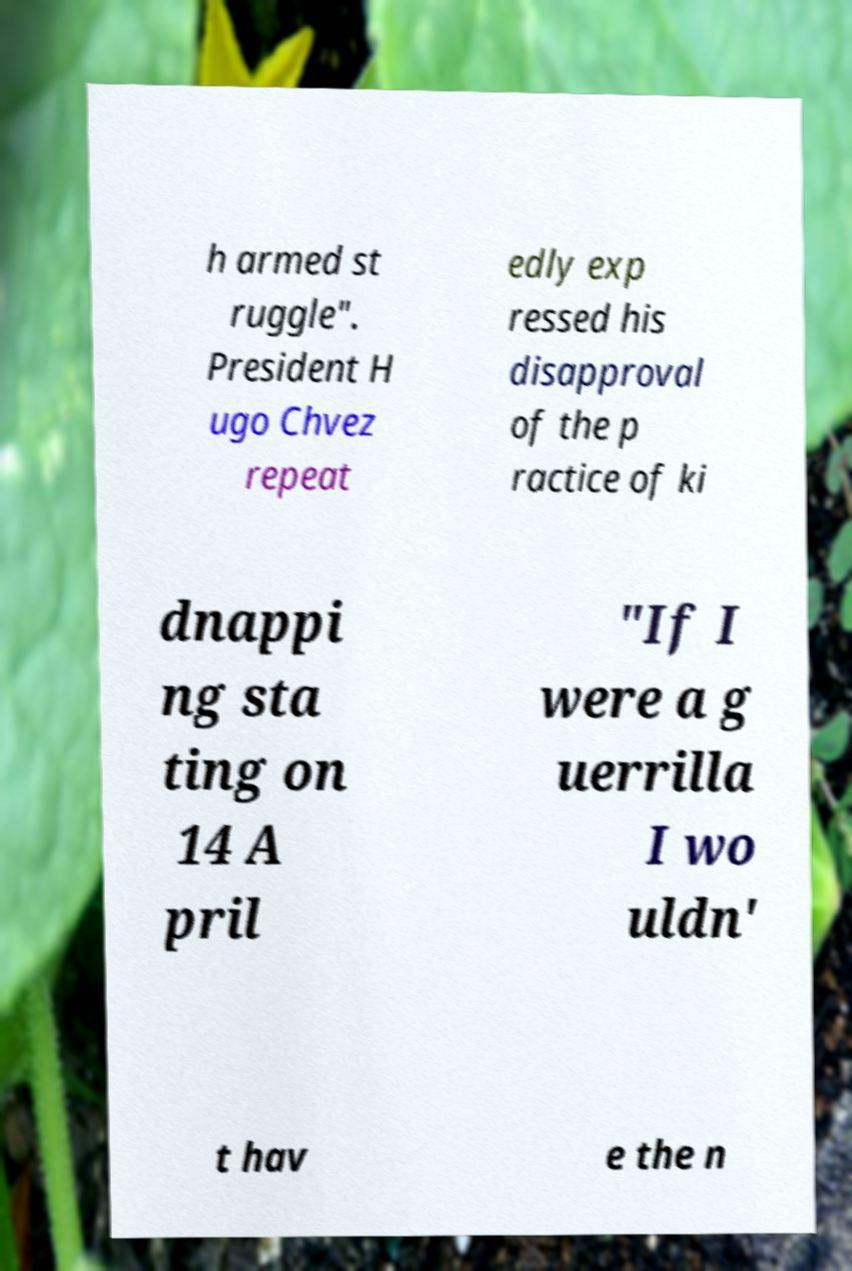Please read and relay the text visible in this image. What does it say? h armed st ruggle". President H ugo Chvez repeat edly exp ressed his disapproval of the p ractice of ki dnappi ng sta ting on 14 A pril "If I were a g uerrilla I wo uldn' t hav e the n 